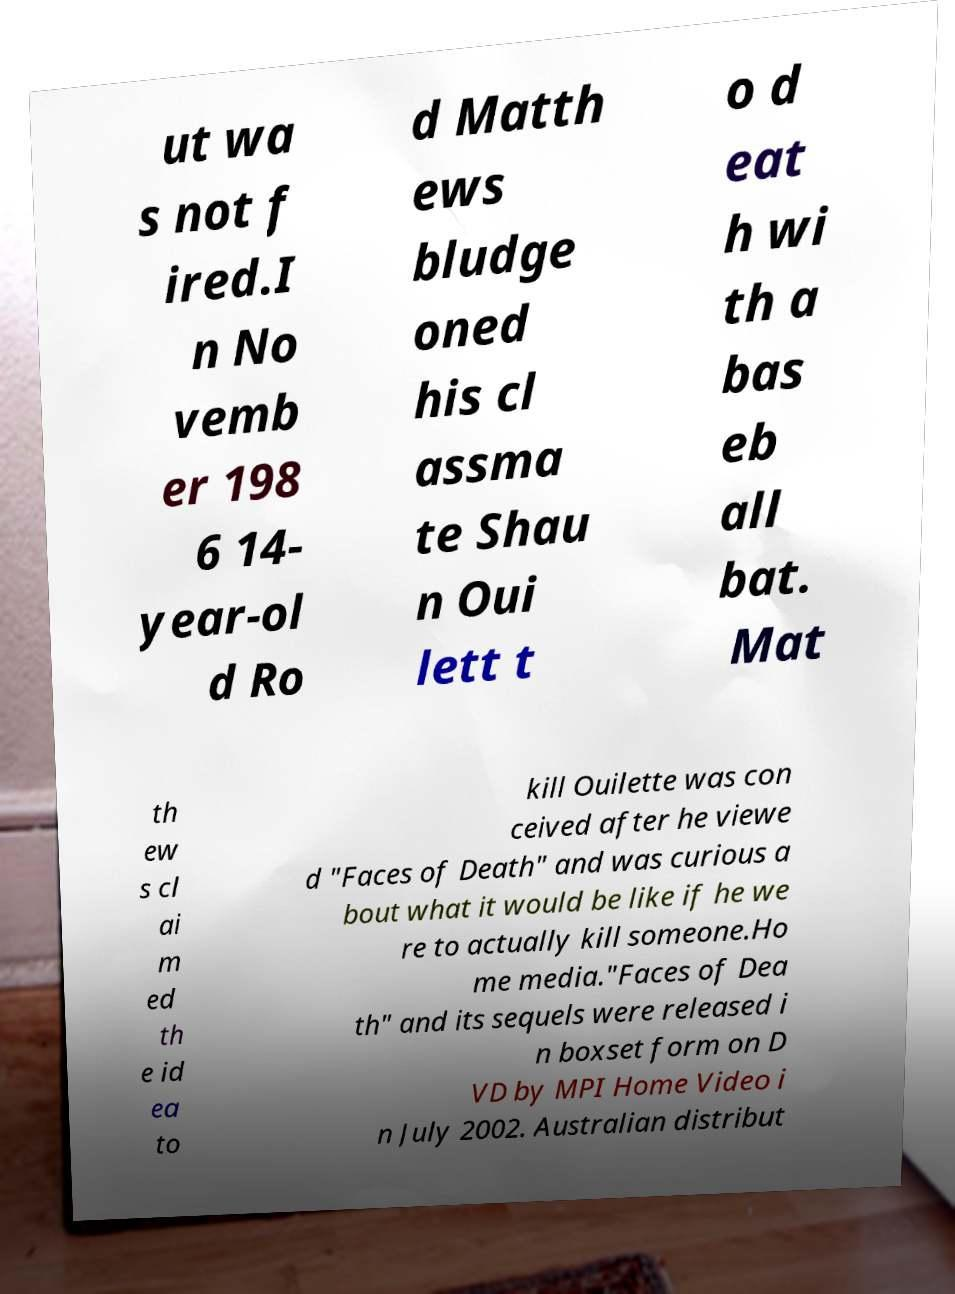Could you assist in decoding the text presented in this image and type it out clearly? ut wa s not f ired.I n No vemb er 198 6 14- year-ol d Ro d Matth ews bludge oned his cl assma te Shau n Oui lett t o d eat h wi th a bas eb all bat. Mat th ew s cl ai m ed th e id ea to kill Ouilette was con ceived after he viewe d "Faces of Death" and was curious a bout what it would be like if he we re to actually kill someone.Ho me media."Faces of Dea th" and its sequels were released i n boxset form on D VD by MPI Home Video i n July 2002. Australian distribut 